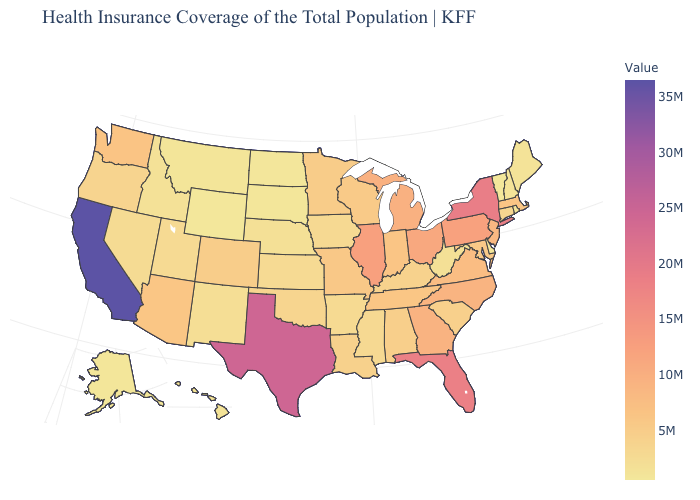Which states have the lowest value in the MidWest?
Be succinct. North Dakota. Does Wyoming have the lowest value in the USA?
Be succinct. Yes. Which states have the lowest value in the South?
Concise answer only. Delaware. Which states hav the highest value in the South?
Short answer required. Texas. Which states have the highest value in the USA?
Be succinct. California. Among the states that border Indiana , does Illinois have the highest value?
Keep it brief. Yes. 